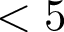<formula> <loc_0><loc_0><loc_500><loc_500>< 5</formula> 